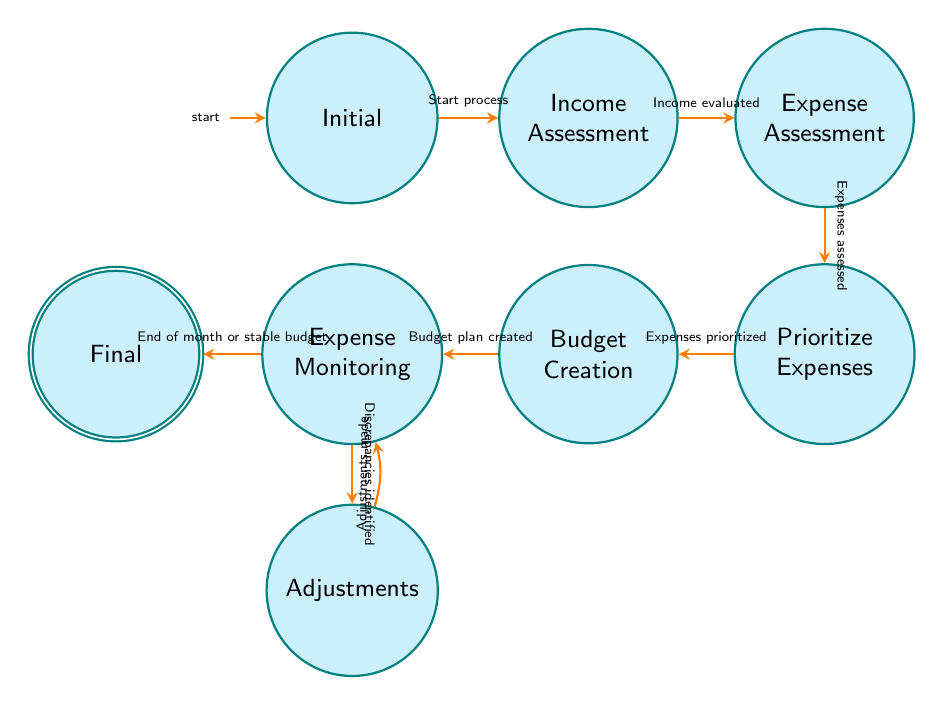What is the starting point in the budget management process? The starting point is the "Initial" state. This is indicated by the state labeled "Initial" in the diagram, which shows that this is where the process begins.
Answer: Initial How many total states are represented in the diagram? The total states are counted by identifying each circle in the diagram representing a state. There are eight circles, thus there are a total of eight states.
Answer: Eight What is the condition needed to transition from "Income Assessment" to "Expense Assessment"? The transition from "Income Assessment" to "Expense Assessment" requires the condition "Income evaluated." This is shown directly on the transition arrow in the diagram.
Answer: Income evaluated What is the final state in the budget management process? The final state is the "Final" state. It is the last labeled state in the diagram, indicating the completion of the budget management cycle.
Answer: Final Which state comes before "Budget Creation"? The state that comes before "Budget Creation" is "Prioritize Expenses." This can be deduced from the directional arrow leading into "Budget Creation" from the "Prioritize Expenses" state.
Answer: Prioritize Expenses What condition leads to making adjustments in the budget? The condition leading to making adjustments is "Discrepancies identified." This indicates that during the "Expense Monitoring" process, discrepancies have triggered the need for adjustments.
Answer: Discrepancies identified What happens after adjustments are made? After adjustments are made, the process transitions back to "Expense Monitoring." This is represented by the bend in the arrow showing the flow returns to monitoring expenses again.
Answer: Expense Monitoring What two factors can lead to reaching the final state? The two factors that can lead to reaching the final state are "End of month" and "stable budget." Both conditions are clearly stated on the arrow leading to the "Final" state.
Answer: End of month or stable budget How many transitions are there from the "Expense Monitoring" state? There are two transitions from the "Expense Monitoring" state. One leads to "Adjustments," and the other leads to "Final." Both transitions can be seen directly adjacent to the "Expense Monitoring" state in the diagram.
Answer: Two 